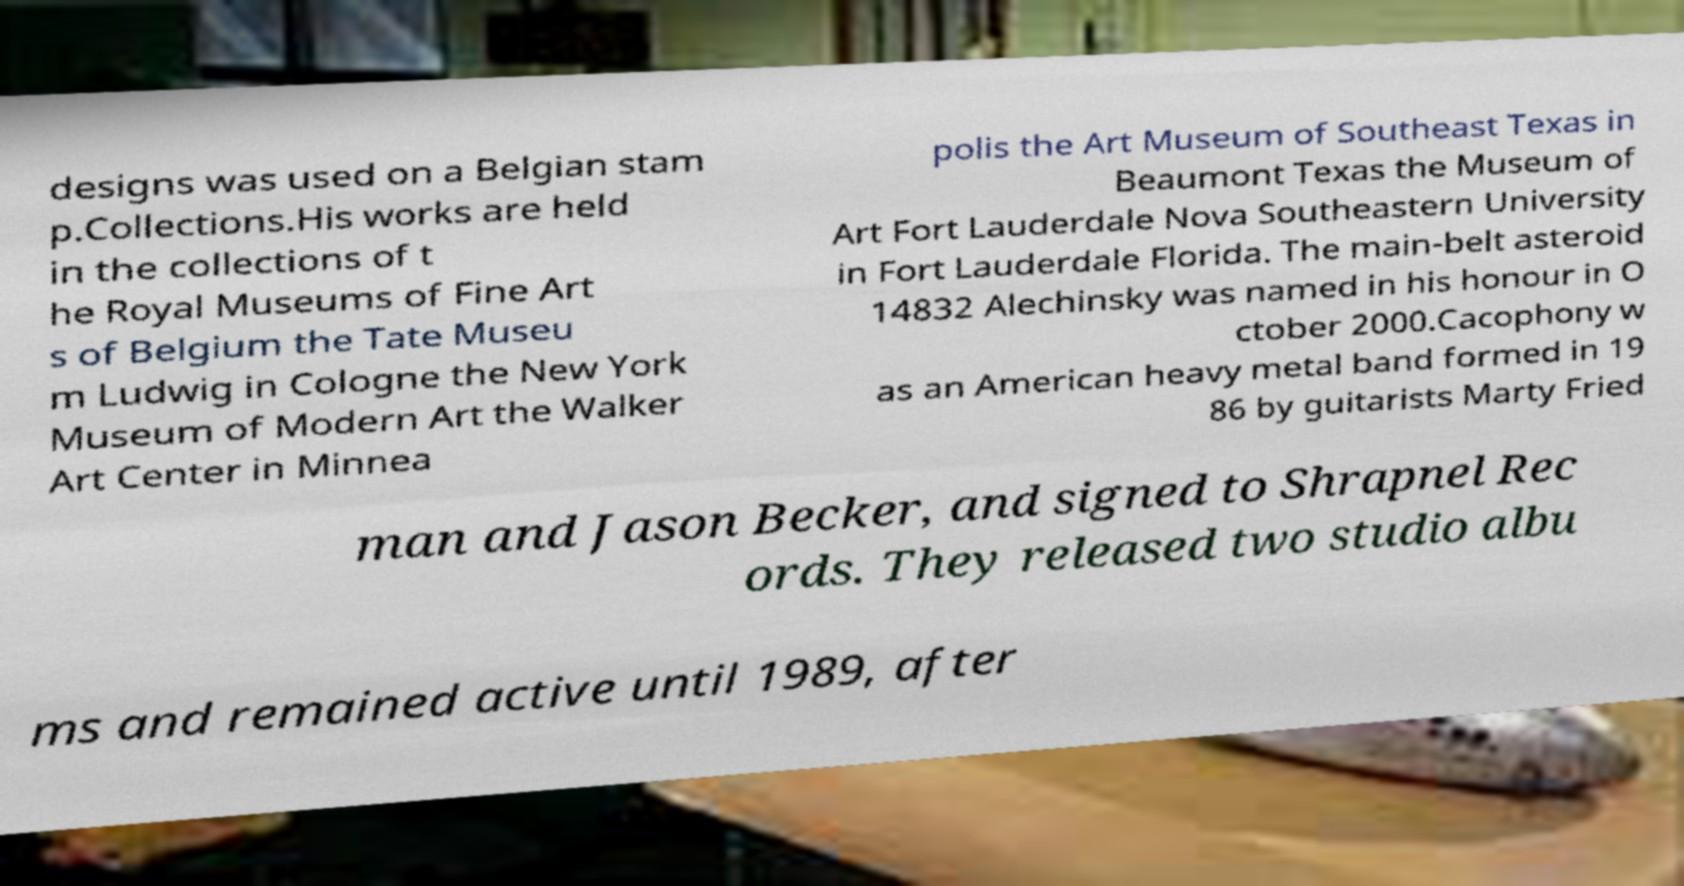Can you read and provide the text displayed in the image?This photo seems to have some interesting text. Can you extract and type it out for me? designs was used on a Belgian stam p.Collections.His works are held in the collections of t he Royal Museums of Fine Art s of Belgium the Tate Museu m Ludwig in Cologne the New York Museum of Modern Art the Walker Art Center in Minnea polis the Art Museum of Southeast Texas in Beaumont Texas the Museum of Art Fort Lauderdale Nova Southeastern University in Fort Lauderdale Florida. The main-belt asteroid 14832 Alechinsky was named in his honour in O ctober 2000.Cacophony w as an American heavy metal band formed in 19 86 by guitarists Marty Fried man and Jason Becker, and signed to Shrapnel Rec ords. They released two studio albu ms and remained active until 1989, after 